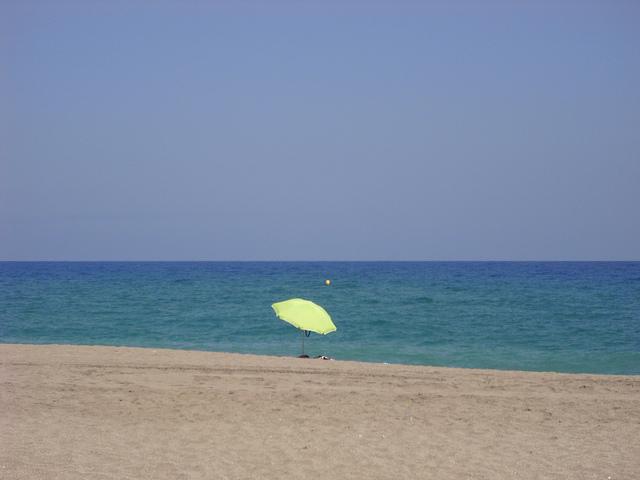Is this umbrella closed?
Short answer required. No. What is the object in the middle?
Concise answer only. Umbrella. What color is the umbrella?
Give a very brief answer. Yellow. What is in the air?
Answer briefly. Umbrella. Is it a sunny day?
Answer briefly. Yes. 